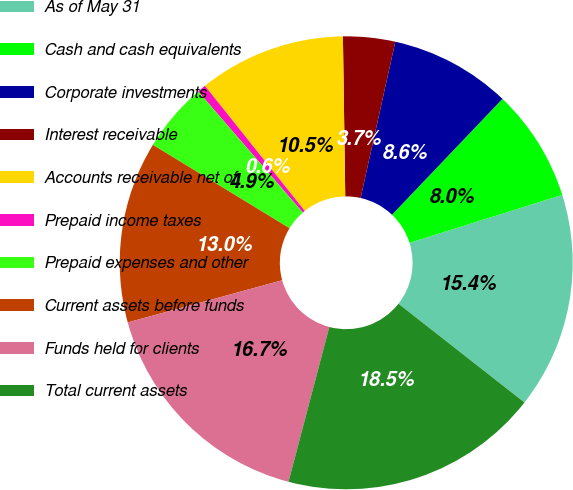<chart> <loc_0><loc_0><loc_500><loc_500><pie_chart><fcel>As of May 31<fcel>Cash and cash equivalents<fcel>Corporate investments<fcel>Interest receivable<fcel>Accounts receivable net of<fcel>Prepaid income taxes<fcel>Prepaid expenses and other<fcel>Current assets before funds<fcel>Funds held for clients<fcel>Total current assets<nl><fcel>15.43%<fcel>8.03%<fcel>8.64%<fcel>3.71%<fcel>10.49%<fcel>0.62%<fcel>4.94%<fcel>12.96%<fcel>16.66%<fcel>18.52%<nl></chart> 